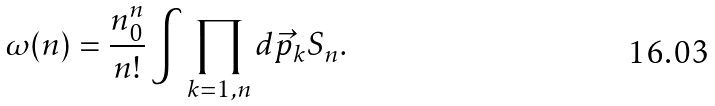Convert formula to latex. <formula><loc_0><loc_0><loc_500><loc_500>\omega ( n ) = \frac { n _ { 0 } ^ { n } } { n ! } \int \prod _ { k = 1 , n } d \vec { p } _ { k } S _ { n } .</formula> 